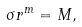<formula> <loc_0><loc_0><loc_500><loc_500>\sigma r ^ { m } = M ,</formula> 